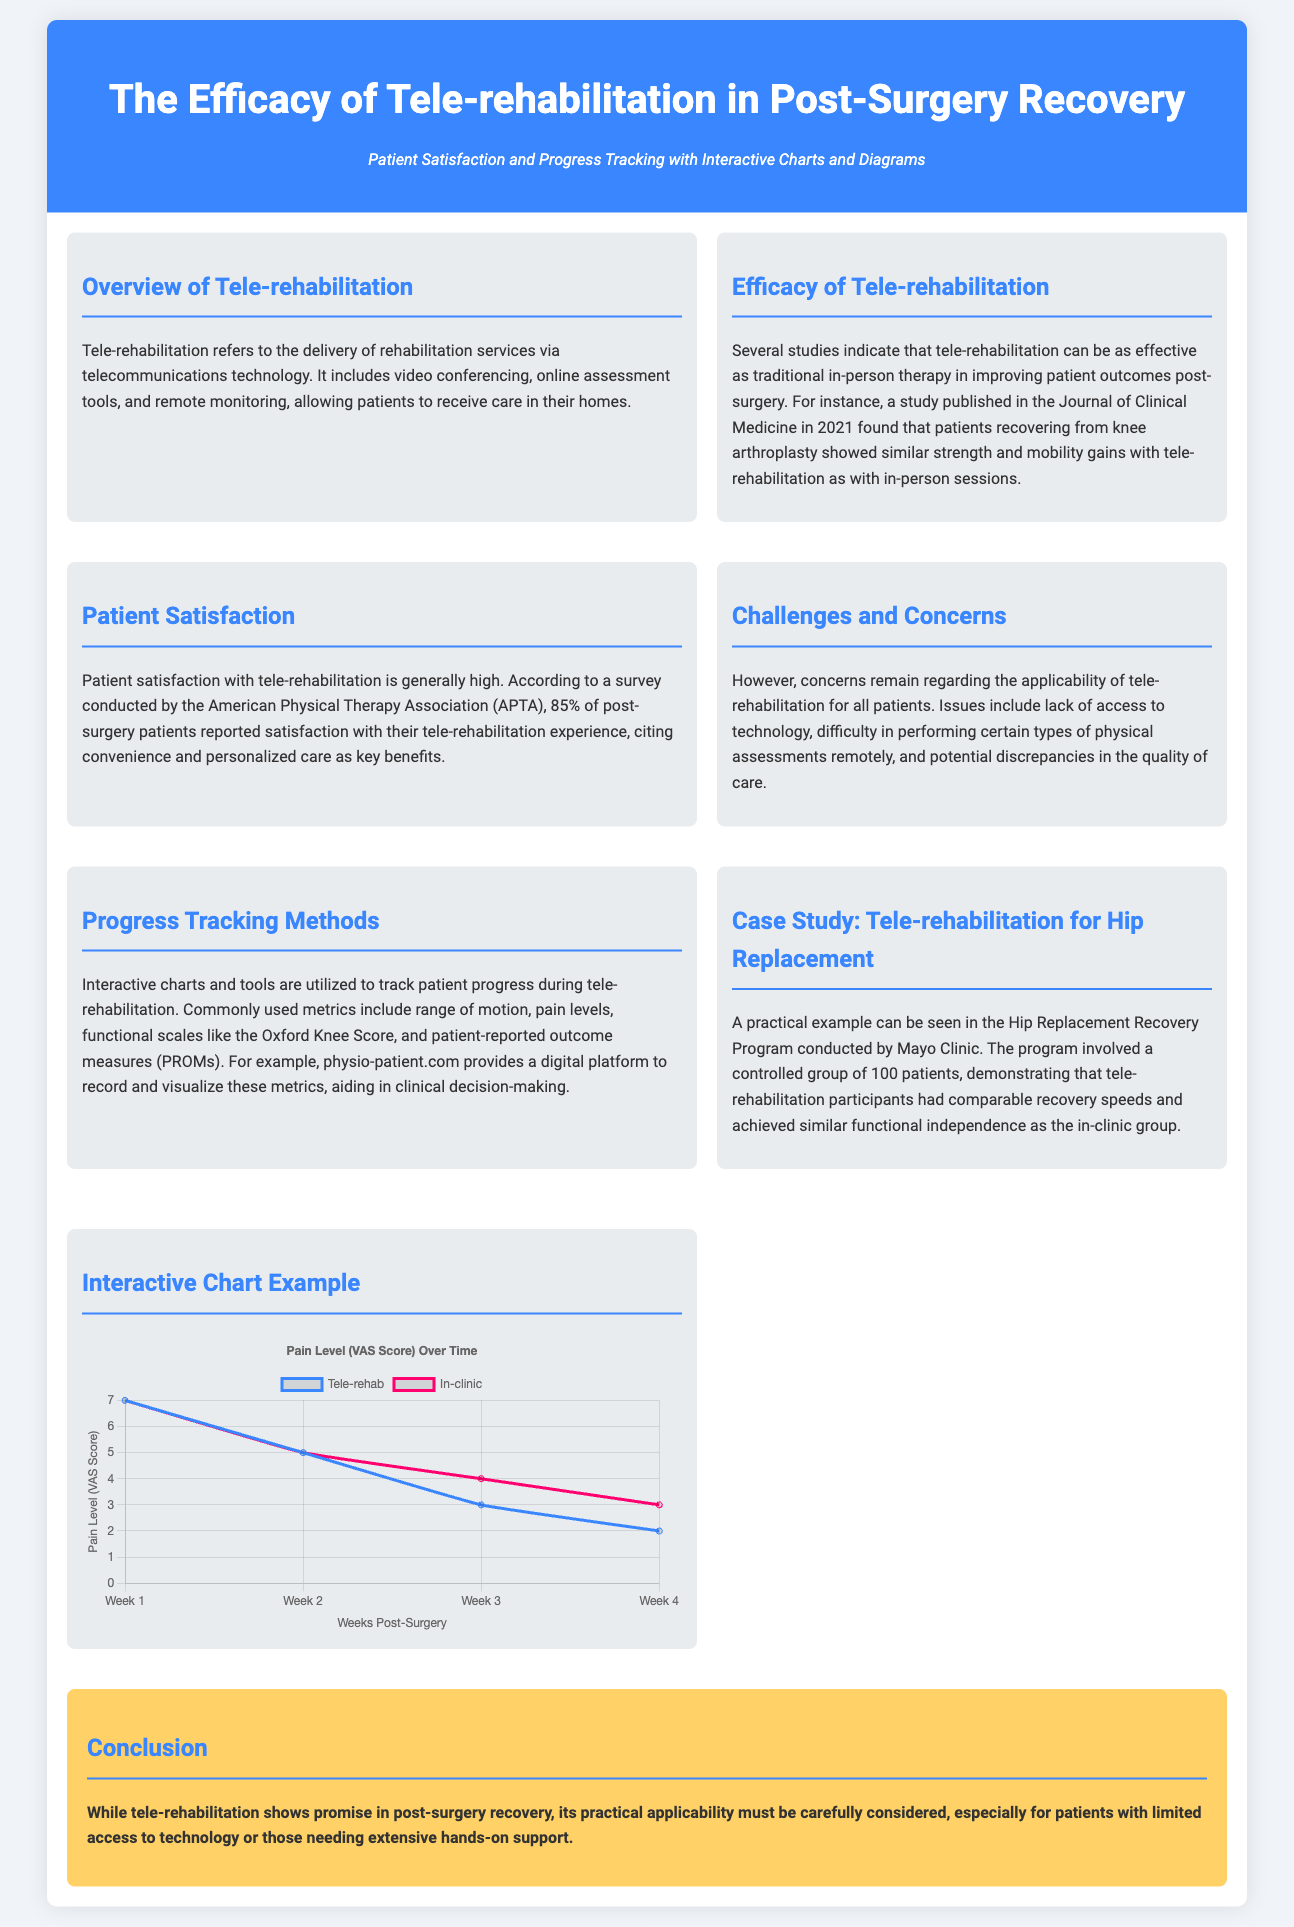What is the primary focus of the infographic? The infographic focuses on the efficacy of tele-rehabilitation in post-surgery recovery, highlighting patient satisfaction and progress tracking.
Answer: Efficacy of tele-rehabilitation in post-surgery recovery What percentage of patients reported satisfaction with tele-rehabilitation? According to a survey by the American Physical Therapy Association, 85% of post-surgery patients reported satisfaction with their tele-rehabilitation experience.
Answer: 85% What is one method mentioned for tracking patient progress? The document indicates that interactive charts and tools are utilized for tracking patient progress, with commonly used metrics including range of motion and pain levels.
Answer: Interactive charts Which study is referenced regarding knee arthroplasty? The study published in the Journal of Clinical Medicine in 2021 is referenced concerning the effectiveness of tele-rehabilitation for patients recovering from knee arthroplasty.
Answer: Journal of Clinical Medicine in 2021 What is the pain level (VAS score) at Week 3 for tele-rehabilitation patients? The tele-rehabilitation patients reported a pain level (VAS score) of 3 at Week 3, as shown in the interactive chart.
Answer: 3 What was the recovery program conducted by Mayo Clinic focused on? The recovery program conducted by Mayo Clinic focused on tele-rehabilitation for hip replacement patients.
Answer: Hip Replacement Recovery Program What issue is mentioned regarding the applicability of tele-rehabilitation? Concerns about lack of access to technology are mentioned as a potential issue regarding the applicability of tele-rehabilitation for all patients.
Answer: Lack of access to technology What does the interactive chart in the infographic illustrate? The interactive chart illustrates pain levels over time for tele-rehabilitation and in-clinic rehabilitation patients, comparing their scores.
Answer: Pain levels over time 